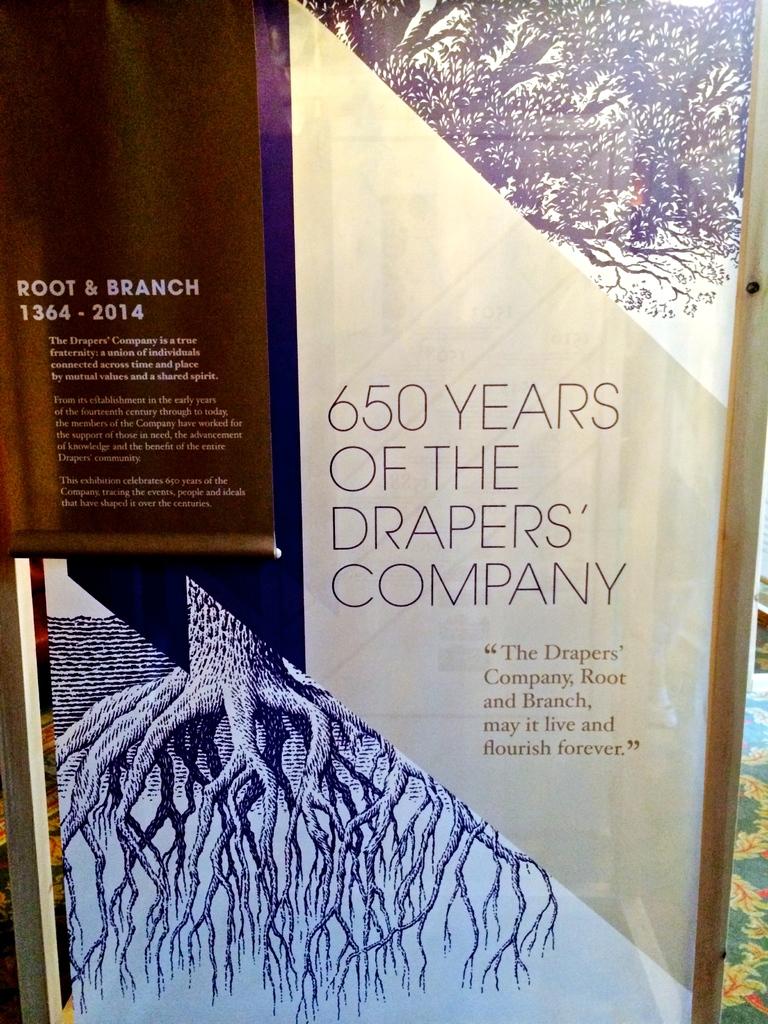How many years has the drapers company been around?
Ensure brevity in your answer.  650. What year did the root & branch started?
Your answer should be very brief. 1364. 